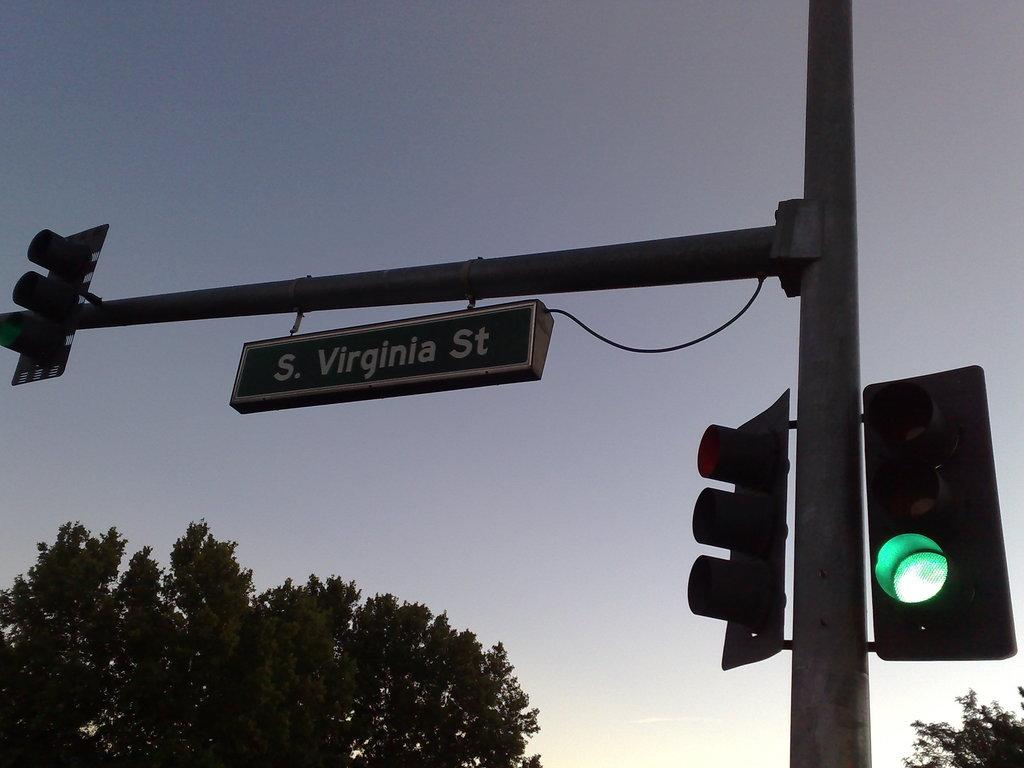What is the main object in the image? There is a name board in the image. What else can be seen in the image besides the name board? There is a pole, traffic signals, trees, and the sky visible in the image. What is the purpose of the pole in the image? The pole is likely used to support the traffic signals. What type of vegetation is present in the image? There are trees in the image. How many fingers can be seen pointing at the map in the image? There is no map or fingers present in the image. 